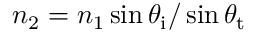<formula> <loc_0><loc_0><loc_500><loc_500>n _ { 2 } = n _ { 1 } \sin \theta _ { i } / \sin \theta _ { t }</formula> 